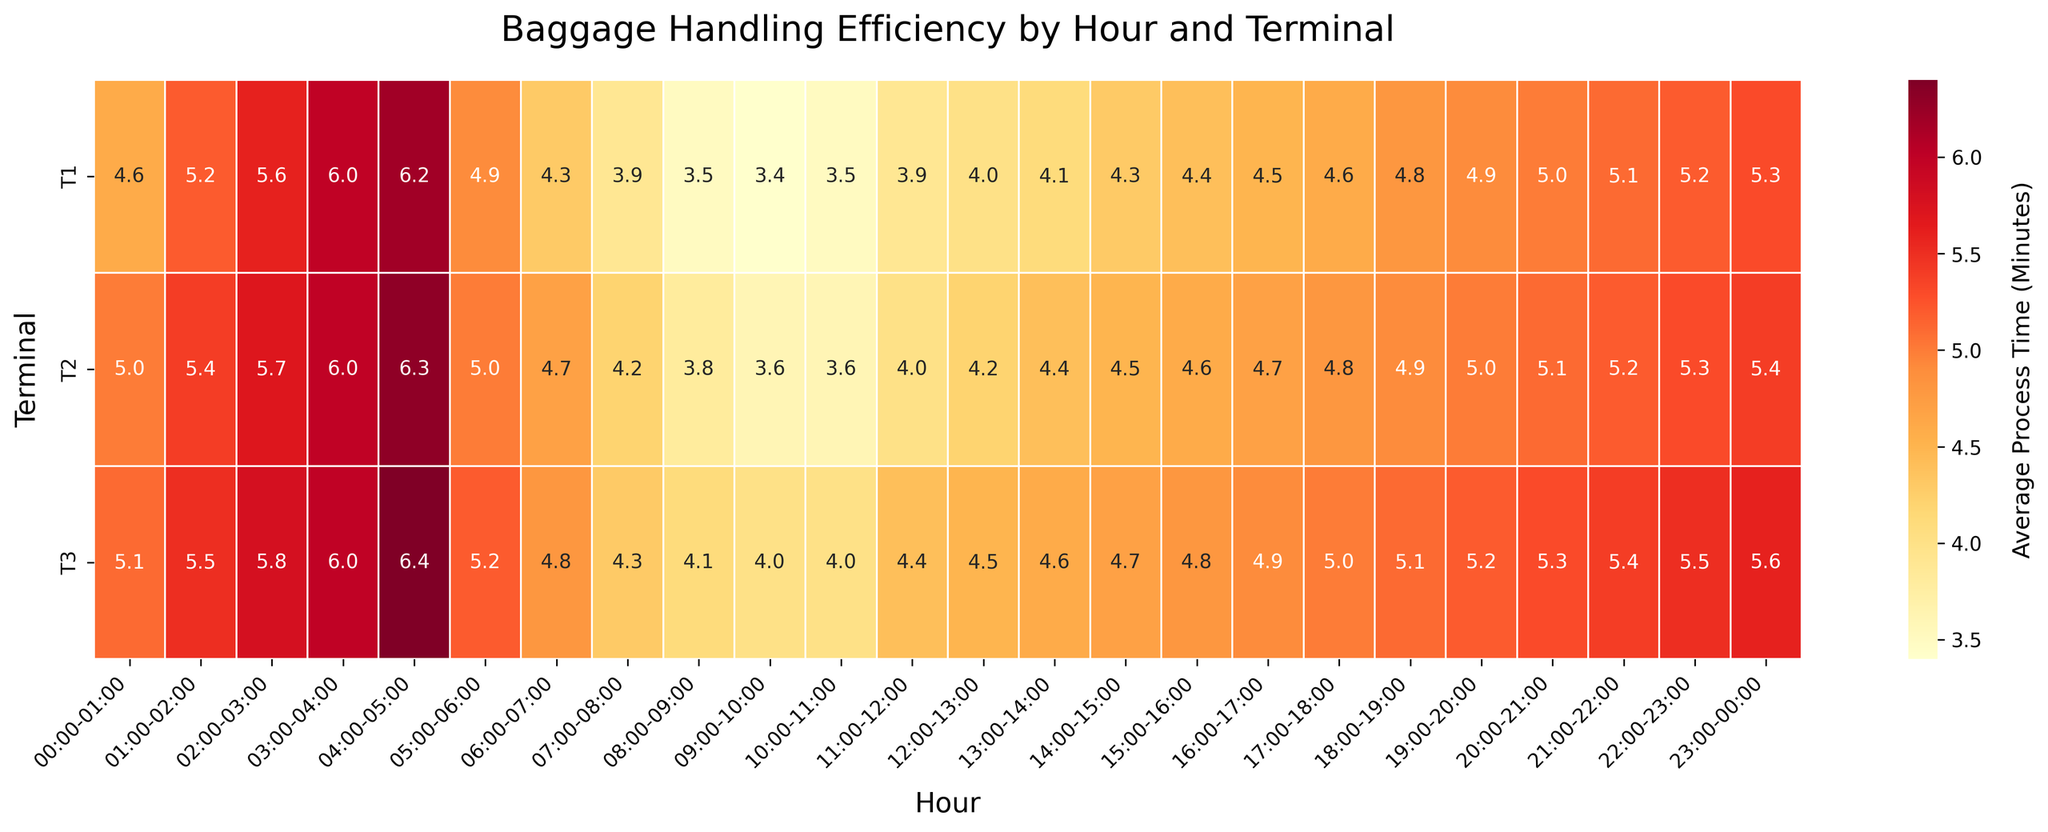what is the title of the figure? The title of the figure is prominently displayed at the top, providing a summary of what the figure represents. It reads "Baggage Handling Efficiency by Hour and Terminal."
Answer: Baggage Handling Efficiency by Hour and Terminal Which terminal has the shortest average processing time in the 09:00-10:00 hour slot? Look at the cell in the 09:00-10:00 hour column for each terminal. Compare the values to find the smallest number, which represents the shortest processing time.
Answer: T1 What's the total number of terminals displayed in the heatmap? Count the number of unique labels on the y-axis, which represent the terminals. The labels T1, T2, and T3 are each listed once.
Answer: 3 Which hour shows the maximum variation in average processing times across all terminals? Compare the values in each column (hour) to find the one with the highest range. The "04:00-05:00" hour shows the maximum variation, with values ranging from 6.2 (T1) to 6.4 (T3).
Answer: 04:00-05:00 Is there an hour where all terminals have the same average processing time? Examine each column (hour) to see if any has the same value in all three cells (representing the terminals). There is no such hour.
Answer: No Which terminal has the consistently lowest processing times from 06:00 to 09:00? Examine the cells for each hour from 06:00 to 09:00 for all terminals. Terminal T1 consistently has the lowest values among the three terminals during these hours.
Answer: T1 What is the average of the processing times for terminal T2 throughout the day? Sum up all the processing times for terminal T2 and divide by the number of hours. The values are (5.0 + 5.4 + 5.7 + 6.0 + 6.3 + 5.0 + 4.7 + 4.2 + 3.8 + 3.6 + 3.6 + 4.0 + 4.2 + 4.4 + 4.5 + 4.6 + 4.7 + 4.8 + 4.9 + 5.0 + 5.1 + 5.2 + 5.3 + 5.4) = 123.5. The average is 123.5/24 = 5.15.
Answer: 5.15 In which hour does Terminal T1 experience the highest average processing time? Locate Terminal T1's row and look for the highest value among the different hours. The highest value is at 04:00-05:00 with 6.2 minutes.
Answer: 04:00-05:00 